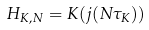Convert formula to latex. <formula><loc_0><loc_0><loc_500><loc_500>H _ { K , N } = K ( j ( N \tau _ { K } ) )</formula> 